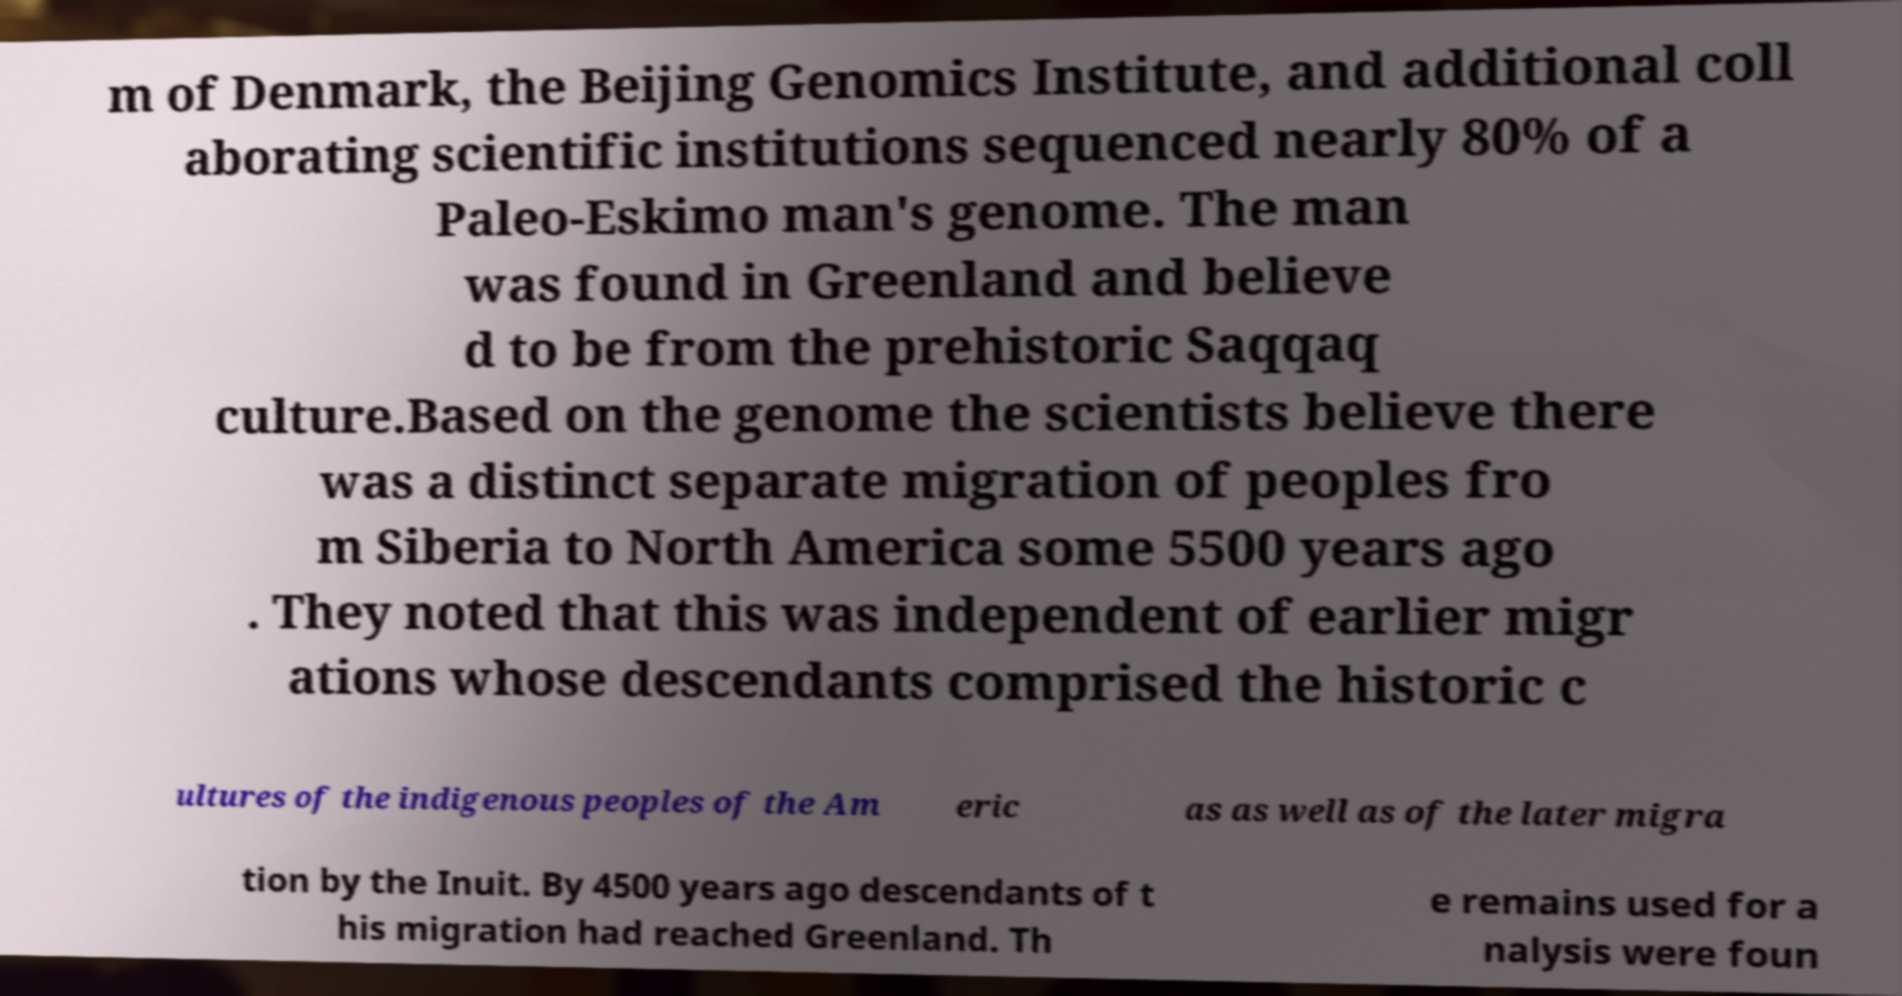There's text embedded in this image that I need extracted. Can you transcribe it verbatim? m of Denmark, the Beijing Genomics Institute, and additional coll aborating scientific institutions sequenced nearly 80% of a Paleo-Eskimo man's genome. The man was found in Greenland and believe d to be from the prehistoric Saqqaq culture.Based on the genome the scientists believe there was a distinct separate migration of peoples fro m Siberia to North America some 5500 years ago . They noted that this was independent of earlier migr ations whose descendants comprised the historic c ultures of the indigenous peoples of the Am eric as as well as of the later migra tion by the Inuit. By 4500 years ago descendants of t his migration had reached Greenland. Th e remains used for a nalysis were foun 